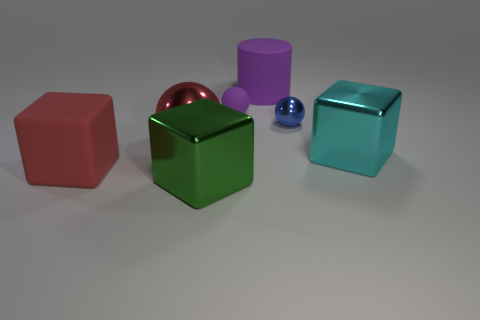Subtract all purple balls. Subtract all brown cylinders. How many balls are left? 2 Add 2 large red balls. How many objects exist? 9 Subtract all cylinders. How many objects are left? 6 Subtract all big red matte cubes. Subtract all cyan shiny things. How many objects are left? 5 Add 1 big red rubber cubes. How many big red rubber cubes are left? 2 Add 5 large balls. How many large balls exist? 6 Subtract 0 purple cubes. How many objects are left? 7 